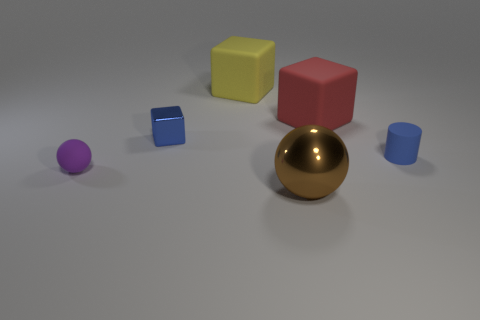What color is the matte thing that is on the left side of the tiny blue metal block?
Give a very brief answer. Purple. The yellow object that is made of the same material as the purple sphere is what size?
Your response must be concise. Large. There is a brown thing that is the same shape as the small purple object; what size is it?
Offer a very short reply. Large. Are there any tiny purple matte objects?
Provide a short and direct response. Yes. How many objects are either things that are behind the brown object or balls?
Provide a succinct answer. 6. There is a red object that is the same size as the brown ball; what is it made of?
Your answer should be very brief. Rubber. There is a small object that is on the right side of the blue thing to the left of the small blue rubber thing; what color is it?
Provide a short and direct response. Blue. What number of tiny purple things are behind the tiny blue metal object?
Ensure brevity in your answer.  0. The rubber cylinder has what color?
Make the answer very short. Blue. How many small objects are red metal balls or brown shiny spheres?
Your answer should be compact. 0. 